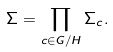Convert formula to latex. <formula><loc_0><loc_0><loc_500><loc_500>\Sigma = \prod _ { c \in G / H } \Sigma _ { c } .</formula> 